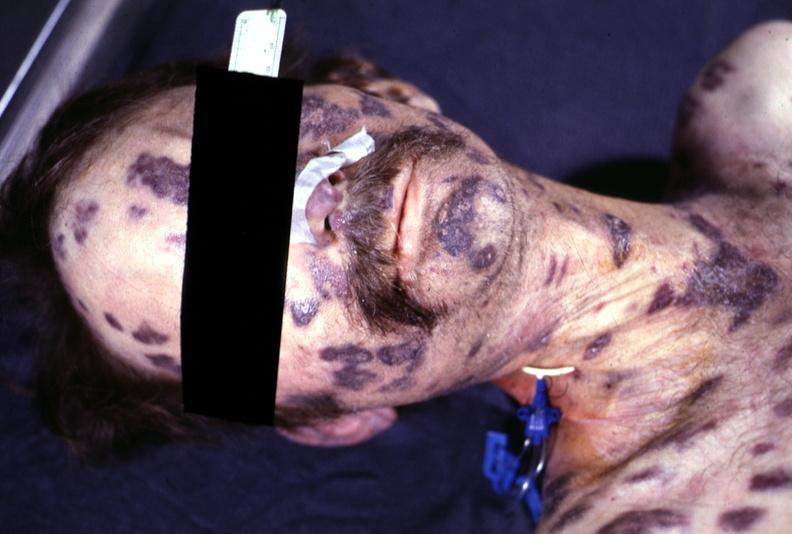does fibrinous peritonitis show skin, kaposi 's sarcoma?
Answer the question using a single word or phrase. No 